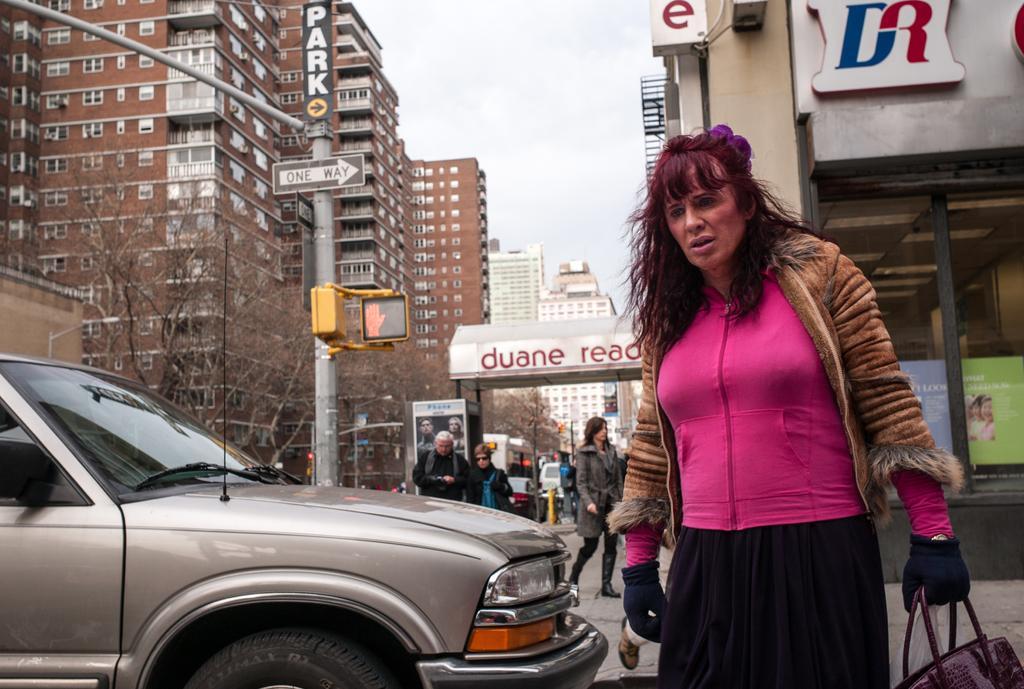How would you summarize this image in a sentence or two? On the right side a woman is walking, she wore pink color top. On the left side there is a car, these are the buildings. At the top it is the sky. 